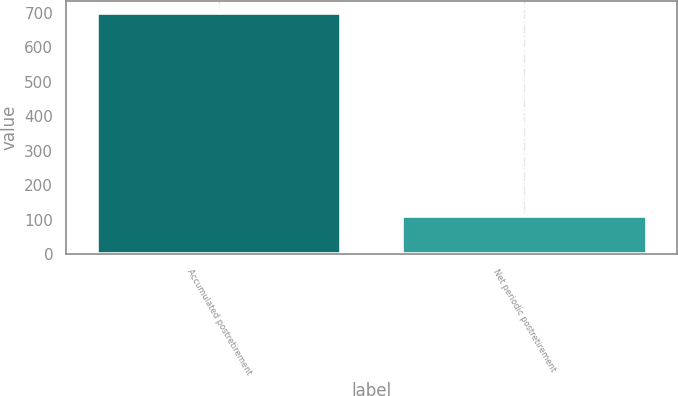Convert chart to OTSL. <chart><loc_0><loc_0><loc_500><loc_500><bar_chart><fcel>Accumulated postretirement<fcel>Net periodic postretirement<nl><fcel>700<fcel>110<nl></chart> 